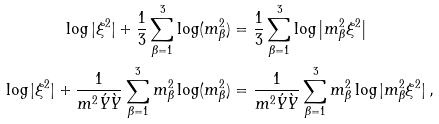Convert formula to latex. <formula><loc_0><loc_0><loc_500><loc_500>\log | \xi ^ { 2 } | + \frac { 1 } { 3 } \sum _ { \beta = 1 } ^ { 3 } \log ( m _ { \beta } ^ { 2 } ) & = \frac { 1 } { 3 } \sum _ { \beta = 1 } ^ { 3 } \log \left | m _ { \beta } ^ { 2 } \xi ^ { 2 } \right | \\ \log | \xi ^ { 2 } | + \frac { 1 } { m ^ { 2 } \acute { Y } \grave { Y } } \sum _ { \beta = 1 } ^ { 3 } m _ { \beta } ^ { 2 } \log ( m _ { \beta } ^ { 2 } ) & = \frac { 1 } { m ^ { 2 } \acute { Y } \grave { Y } } \sum _ { \beta = 1 } ^ { 3 } m _ { \beta } ^ { 2 } \log | m _ { \beta } ^ { 2 } \xi ^ { 2 } | \, ,</formula> 